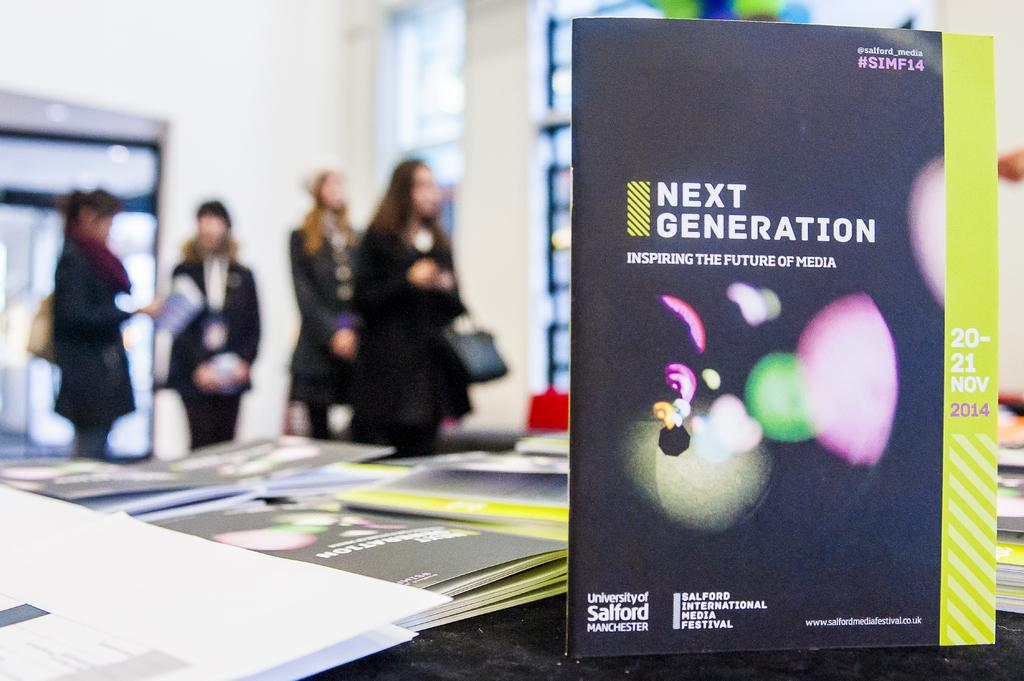Who or what can be seen in the image? There are people in the image. What else is present in the image besides the people? There are posters with text and images, as well as a wall with objects. What type of cracker is being discussed by the committee in the image? There is no mention of a committee or cracker in the image; it only mentions people and posters with text and images. 